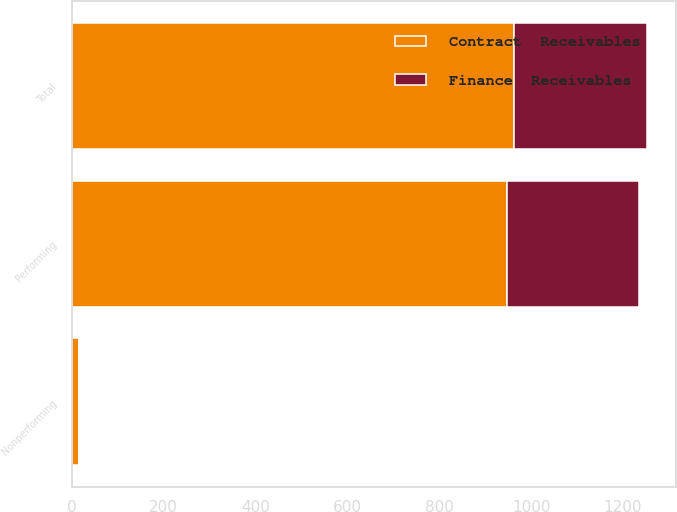Convert chart to OTSL. <chart><loc_0><loc_0><loc_500><loc_500><stacked_bar_chart><ecel><fcel>Performing<fcel>Nonperforming<fcel>Total<nl><fcel>Contract  Receivables<fcel>947.8<fcel>15.2<fcel>963<nl><fcel>Finance  Receivables<fcel>287.8<fcel>1<fcel>288.8<nl></chart> 